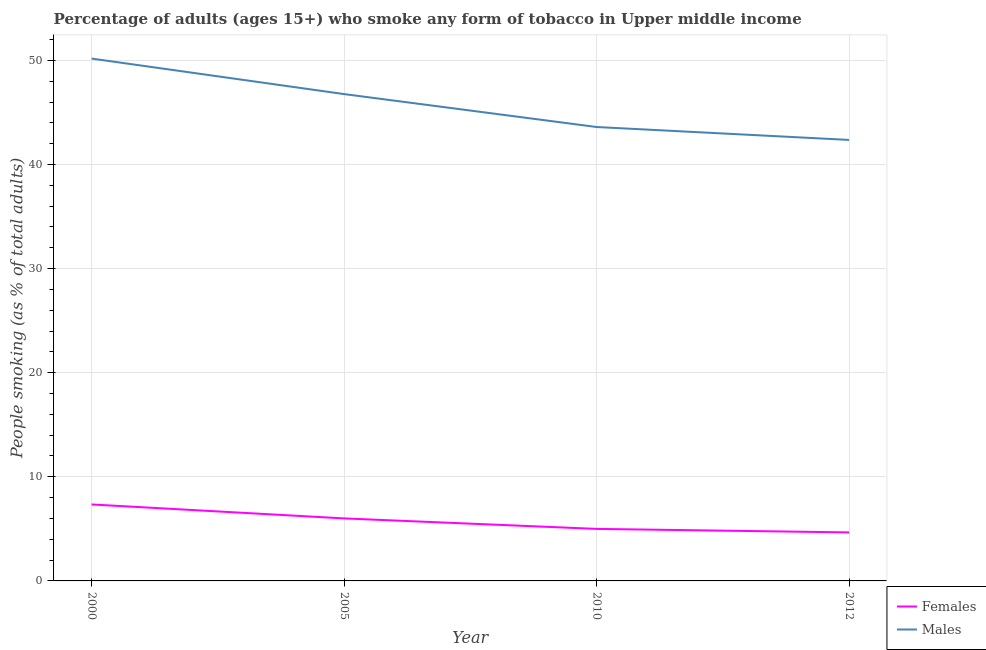How many different coloured lines are there?
Provide a succinct answer. 2. What is the percentage of females who smoke in 2012?
Your answer should be compact. 4.66. Across all years, what is the maximum percentage of males who smoke?
Offer a very short reply. 50.18. Across all years, what is the minimum percentage of females who smoke?
Your response must be concise. 4.66. What is the total percentage of females who smoke in the graph?
Provide a succinct answer. 23.01. What is the difference between the percentage of males who smoke in 2010 and that in 2012?
Your answer should be very brief. 1.24. What is the difference between the percentage of females who smoke in 2012 and the percentage of males who smoke in 2000?
Offer a terse response. -45.51. What is the average percentage of males who smoke per year?
Your answer should be compact. 45.73. In the year 2005, what is the difference between the percentage of females who smoke and percentage of males who smoke?
Make the answer very short. -40.76. What is the ratio of the percentage of females who smoke in 2005 to that in 2010?
Give a very brief answer. 1.2. What is the difference between the highest and the second highest percentage of males who smoke?
Offer a very short reply. 3.41. What is the difference between the highest and the lowest percentage of males who smoke?
Your response must be concise. 7.81. Is the sum of the percentage of males who smoke in 2010 and 2012 greater than the maximum percentage of females who smoke across all years?
Ensure brevity in your answer.  Yes. Is the percentage of males who smoke strictly greater than the percentage of females who smoke over the years?
Make the answer very short. Yes. What is the difference between two consecutive major ticks on the Y-axis?
Keep it short and to the point. 10. Are the values on the major ticks of Y-axis written in scientific E-notation?
Provide a succinct answer. No. Does the graph contain any zero values?
Your answer should be compact. No. What is the title of the graph?
Keep it short and to the point. Percentage of adults (ages 15+) who smoke any form of tobacco in Upper middle income. What is the label or title of the Y-axis?
Offer a very short reply. People smoking (as % of total adults). What is the People smoking (as % of total adults) in Females in 2000?
Ensure brevity in your answer.  7.35. What is the People smoking (as % of total adults) of Males in 2000?
Ensure brevity in your answer.  50.18. What is the People smoking (as % of total adults) in Females in 2005?
Offer a terse response. 6.01. What is the People smoking (as % of total adults) of Males in 2005?
Offer a terse response. 46.76. What is the People smoking (as % of total adults) of Females in 2010?
Offer a terse response. 5. What is the People smoking (as % of total adults) in Males in 2010?
Make the answer very short. 43.6. What is the People smoking (as % of total adults) in Females in 2012?
Ensure brevity in your answer.  4.66. What is the People smoking (as % of total adults) in Males in 2012?
Provide a succinct answer. 42.36. Across all years, what is the maximum People smoking (as % of total adults) of Females?
Give a very brief answer. 7.35. Across all years, what is the maximum People smoking (as % of total adults) of Males?
Keep it short and to the point. 50.18. Across all years, what is the minimum People smoking (as % of total adults) in Females?
Offer a terse response. 4.66. Across all years, what is the minimum People smoking (as % of total adults) in Males?
Provide a succinct answer. 42.36. What is the total People smoking (as % of total adults) of Females in the graph?
Your answer should be compact. 23.01. What is the total People smoking (as % of total adults) in Males in the graph?
Give a very brief answer. 182.9. What is the difference between the People smoking (as % of total adults) in Females in 2000 and that in 2005?
Provide a succinct answer. 1.34. What is the difference between the People smoking (as % of total adults) of Males in 2000 and that in 2005?
Keep it short and to the point. 3.41. What is the difference between the People smoking (as % of total adults) of Females in 2000 and that in 2010?
Provide a short and direct response. 2.35. What is the difference between the People smoking (as % of total adults) in Males in 2000 and that in 2010?
Ensure brevity in your answer.  6.57. What is the difference between the People smoking (as % of total adults) in Females in 2000 and that in 2012?
Provide a short and direct response. 2.68. What is the difference between the People smoking (as % of total adults) in Males in 2000 and that in 2012?
Give a very brief answer. 7.81. What is the difference between the People smoking (as % of total adults) in Females in 2005 and that in 2010?
Offer a very short reply. 1.01. What is the difference between the People smoking (as % of total adults) of Males in 2005 and that in 2010?
Ensure brevity in your answer.  3.16. What is the difference between the People smoking (as % of total adults) of Females in 2005 and that in 2012?
Your answer should be compact. 1.34. What is the difference between the People smoking (as % of total adults) in Males in 2005 and that in 2012?
Provide a succinct answer. 4.4. What is the difference between the People smoking (as % of total adults) of Females in 2010 and that in 2012?
Make the answer very short. 0.34. What is the difference between the People smoking (as % of total adults) of Males in 2010 and that in 2012?
Your answer should be very brief. 1.24. What is the difference between the People smoking (as % of total adults) in Females in 2000 and the People smoking (as % of total adults) in Males in 2005?
Make the answer very short. -39.42. What is the difference between the People smoking (as % of total adults) in Females in 2000 and the People smoking (as % of total adults) in Males in 2010?
Keep it short and to the point. -36.26. What is the difference between the People smoking (as % of total adults) in Females in 2000 and the People smoking (as % of total adults) in Males in 2012?
Ensure brevity in your answer.  -35.02. What is the difference between the People smoking (as % of total adults) in Females in 2005 and the People smoking (as % of total adults) in Males in 2010?
Provide a short and direct response. -37.6. What is the difference between the People smoking (as % of total adults) in Females in 2005 and the People smoking (as % of total adults) in Males in 2012?
Offer a very short reply. -36.36. What is the difference between the People smoking (as % of total adults) of Females in 2010 and the People smoking (as % of total adults) of Males in 2012?
Ensure brevity in your answer.  -37.36. What is the average People smoking (as % of total adults) in Females per year?
Offer a very short reply. 5.75. What is the average People smoking (as % of total adults) in Males per year?
Keep it short and to the point. 45.73. In the year 2000, what is the difference between the People smoking (as % of total adults) in Females and People smoking (as % of total adults) in Males?
Provide a succinct answer. -42.83. In the year 2005, what is the difference between the People smoking (as % of total adults) in Females and People smoking (as % of total adults) in Males?
Your response must be concise. -40.76. In the year 2010, what is the difference between the People smoking (as % of total adults) in Females and People smoking (as % of total adults) in Males?
Provide a short and direct response. -38.6. In the year 2012, what is the difference between the People smoking (as % of total adults) of Females and People smoking (as % of total adults) of Males?
Your answer should be very brief. -37.7. What is the ratio of the People smoking (as % of total adults) of Females in 2000 to that in 2005?
Provide a succinct answer. 1.22. What is the ratio of the People smoking (as % of total adults) in Males in 2000 to that in 2005?
Ensure brevity in your answer.  1.07. What is the ratio of the People smoking (as % of total adults) in Females in 2000 to that in 2010?
Your answer should be very brief. 1.47. What is the ratio of the People smoking (as % of total adults) of Males in 2000 to that in 2010?
Make the answer very short. 1.15. What is the ratio of the People smoking (as % of total adults) of Females in 2000 to that in 2012?
Keep it short and to the point. 1.58. What is the ratio of the People smoking (as % of total adults) in Males in 2000 to that in 2012?
Your response must be concise. 1.18. What is the ratio of the People smoking (as % of total adults) in Females in 2005 to that in 2010?
Offer a terse response. 1.2. What is the ratio of the People smoking (as % of total adults) in Males in 2005 to that in 2010?
Give a very brief answer. 1.07. What is the ratio of the People smoking (as % of total adults) of Females in 2005 to that in 2012?
Provide a short and direct response. 1.29. What is the ratio of the People smoking (as % of total adults) in Males in 2005 to that in 2012?
Your answer should be very brief. 1.1. What is the ratio of the People smoking (as % of total adults) of Females in 2010 to that in 2012?
Keep it short and to the point. 1.07. What is the ratio of the People smoking (as % of total adults) in Males in 2010 to that in 2012?
Give a very brief answer. 1.03. What is the difference between the highest and the second highest People smoking (as % of total adults) of Females?
Keep it short and to the point. 1.34. What is the difference between the highest and the second highest People smoking (as % of total adults) of Males?
Your response must be concise. 3.41. What is the difference between the highest and the lowest People smoking (as % of total adults) of Females?
Provide a succinct answer. 2.68. What is the difference between the highest and the lowest People smoking (as % of total adults) in Males?
Ensure brevity in your answer.  7.81. 